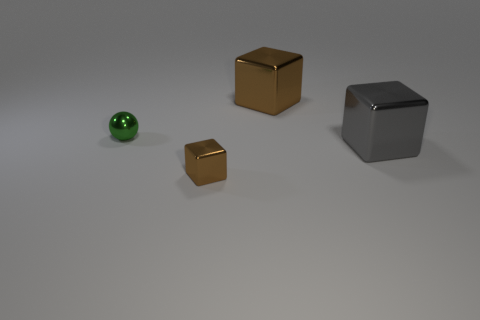Subtract all big metal blocks. How many blocks are left? 1 Subtract all brown blocks. How many blocks are left? 1 Subtract all cubes. How many objects are left? 1 Add 1 gray things. How many objects exist? 5 Subtract all red spheres. Subtract all brown cylinders. How many spheres are left? 1 Subtract all purple cylinders. How many blue blocks are left? 0 Subtract all small red cylinders. Subtract all tiny shiny things. How many objects are left? 2 Add 1 metallic objects. How many metallic objects are left? 5 Add 3 small green metal things. How many small green metal things exist? 4 Subtract 1 green spheres. How many objects are left? 3 